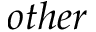Convert formula to latex. <formula><loc_0><loc_0><loc_500><loc_500>o t h e r</formula> 